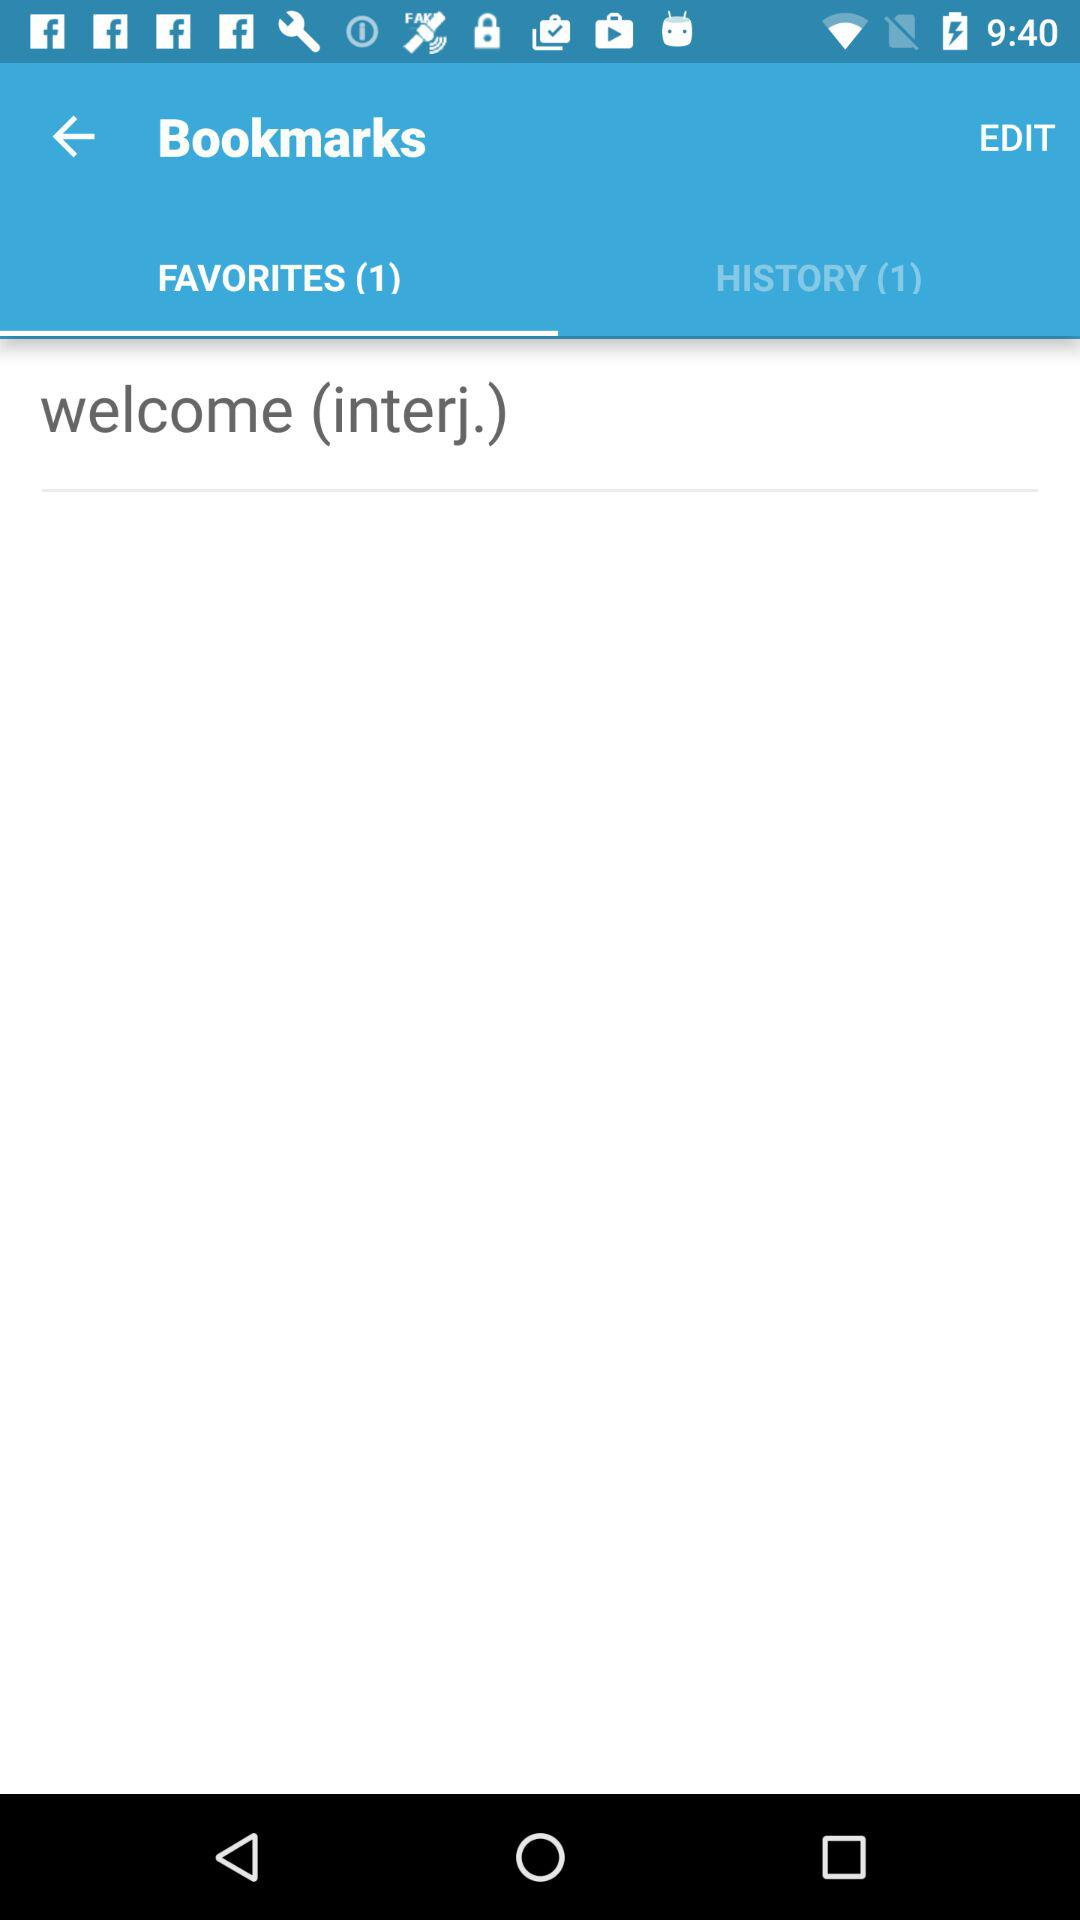How many items in total are there in the "HISTORY"? There are a total of 1 item in the "HISTORY". 